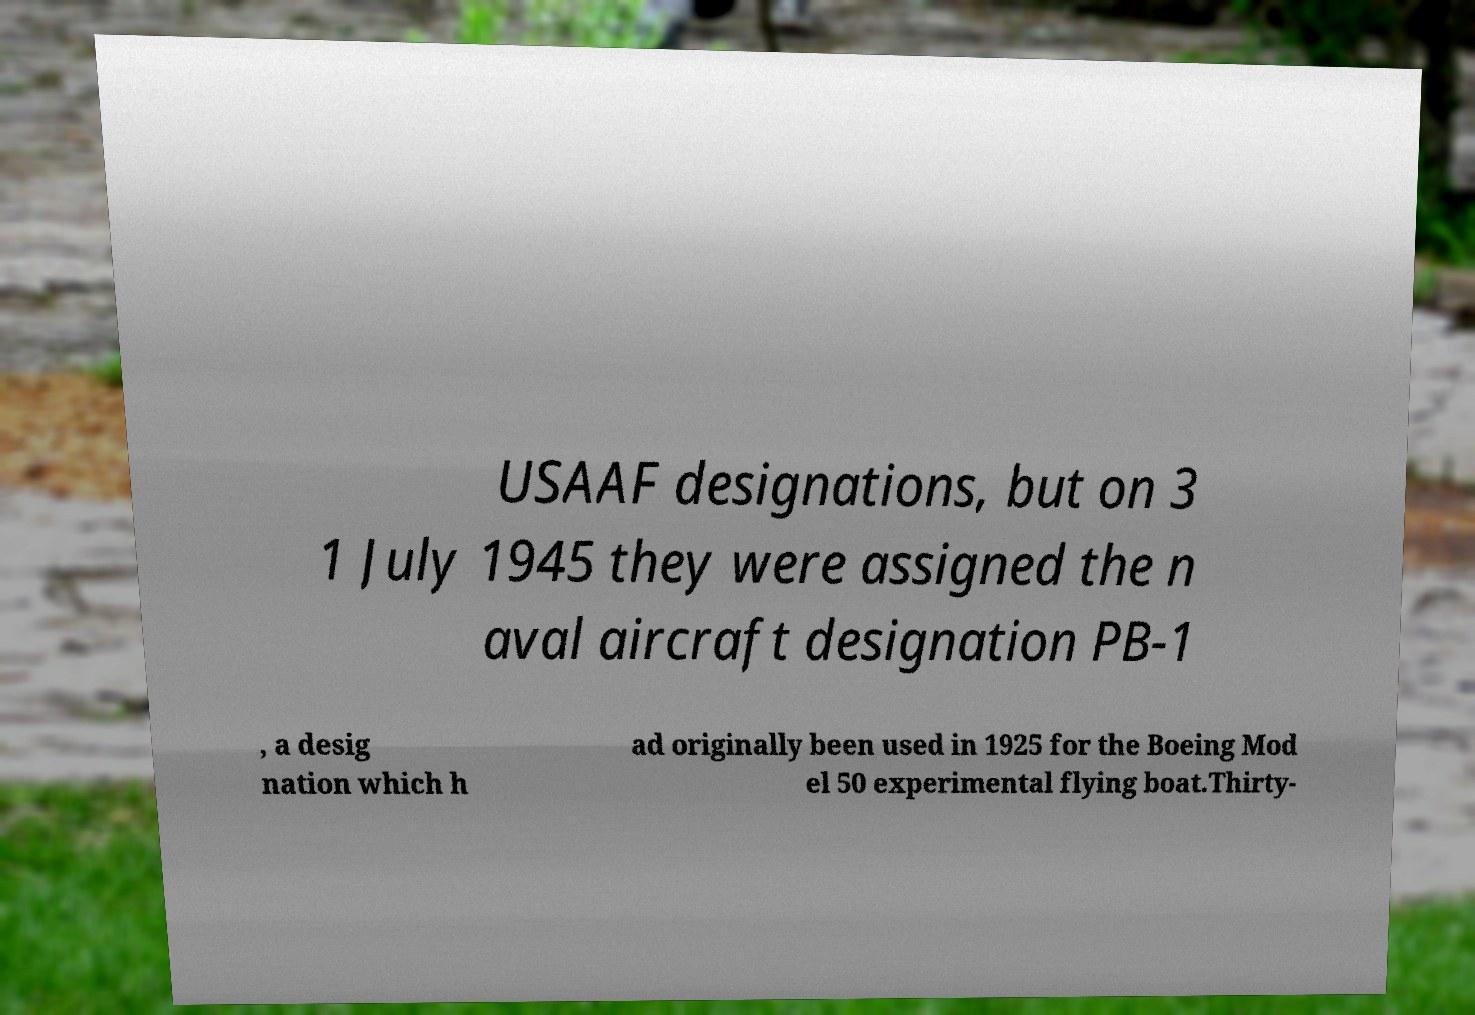Please read and relay the text visible in this image. What does it say? USAAF designations, but on 3 1 July 1945 they were assigned the n aval aircraft designation PB-1 , a desig nation which h ad originally been used in 1925 for the Boeing Mod el 50 experimental flying boat.Thirty- 